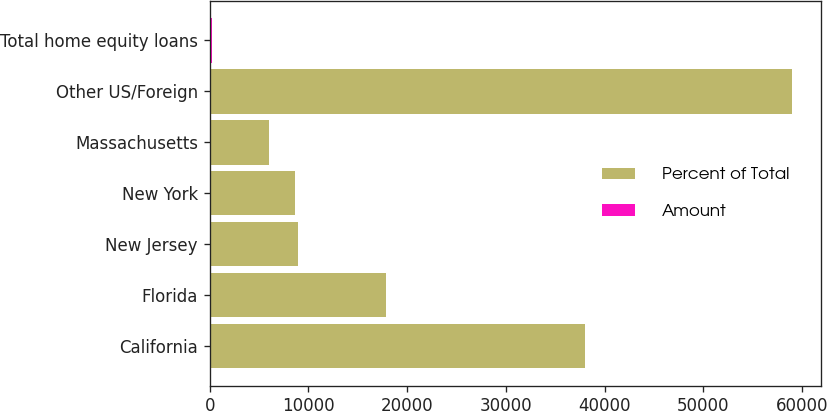<chart> <loc_0><loc_0><loc_500><loc_500><stacked_bar_chart><ecel><fcel>California<fcel>Florida<fcel>New Jersey<fcel>New York<fcel>Massachusetts<fcel>Other US/Foreign<fcel>Total home equity loans<nl><fcel>Percent of Total<fcel>38015<fcel>17893<fcel>8929<fcel>8602<fcel>6008<fcel>58937<fcel>100<nl><fcel>Amount<fcel>27.5<fcel>12.9<fcel>6.5<fcel>6.2<fcel>4.3<fcel>42.6<fcel>100<nl></chart> 